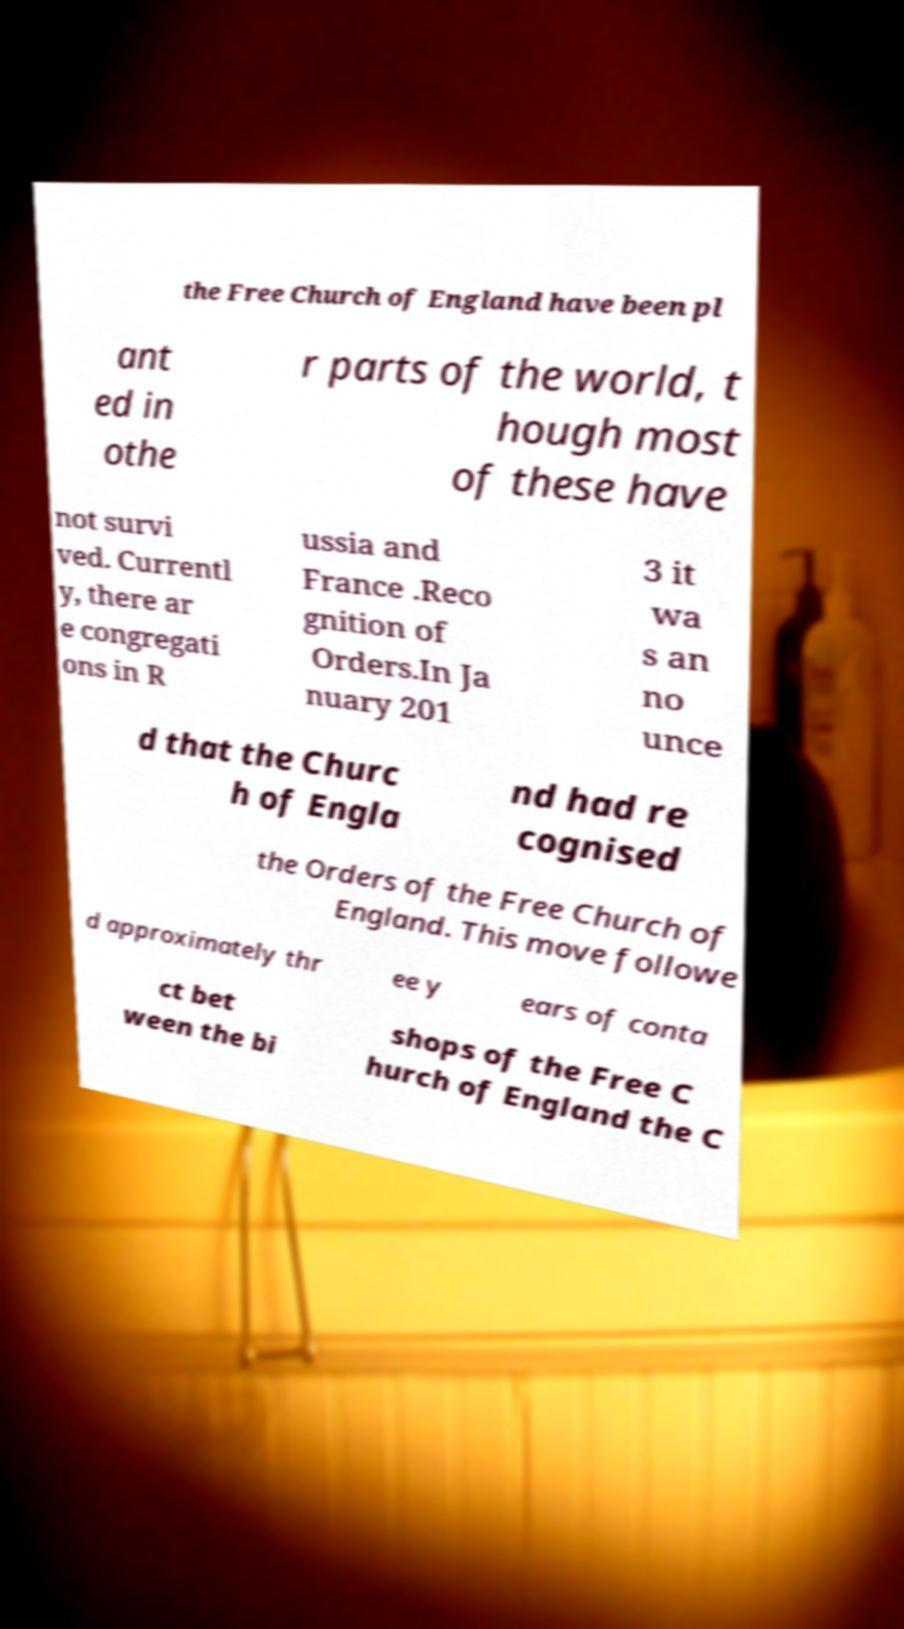What messages or text are displayed in this image? I need them in a readable, typed format. the Free Church of England have been pl ant ed in othe r parts of the world, t hough most of these have not survi ved. Currentl y, there ar e congregati ons in R ussia and France .Reco gnition of Orders.In Ja nuary 201 3 it wa s an no unce d that the Churc h of Engla nd had re cognised the Orders of the Free Church of England. This move followe d approximately thr ee y ears of conta ct bet ween the bi shops of the Free C hurch of England the C 